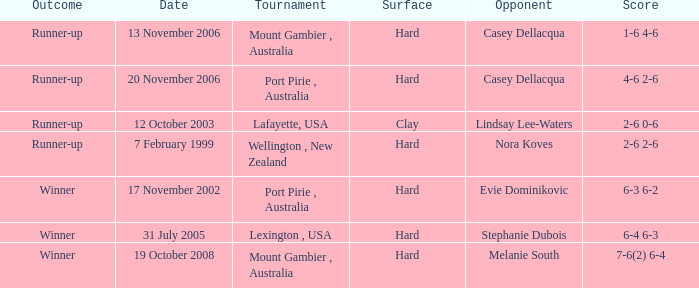What is the outcome for someone competing against lindsay lee-waters? Runner-up. 